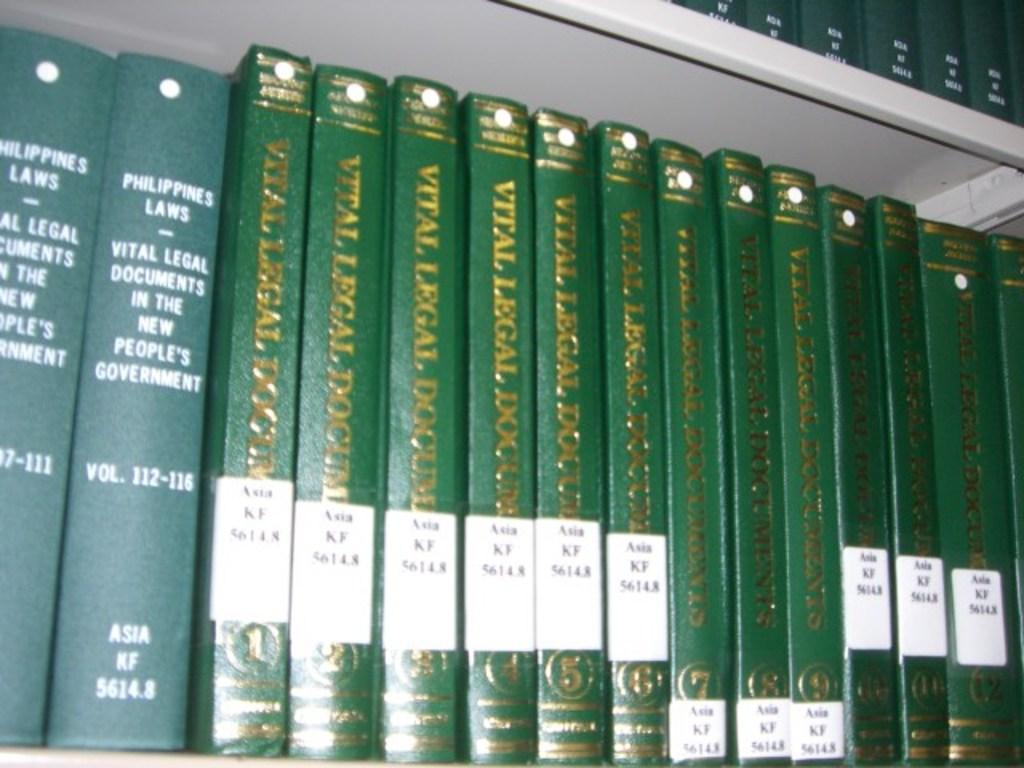What is the title of these works?
Provide a succinct answer. Vital legal documents. 